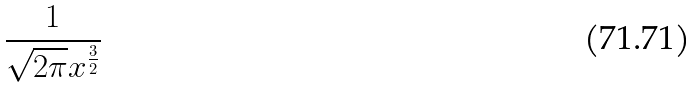<formula> <loc_0><loc_0><loc_500><loc_500>\frac { 1 } { \sqrt { 2 \pi } x ^ { \frac { 3 } { 2 } } }</formula> 